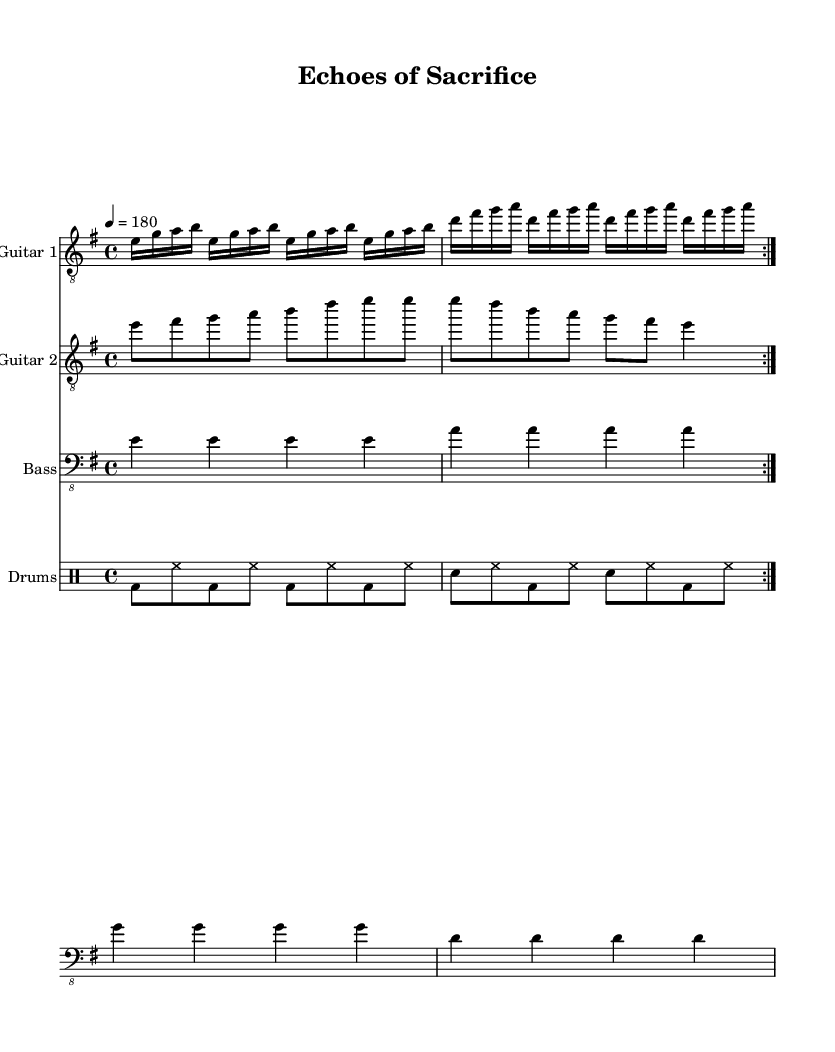What is the key signature of this music? The key signature is indicated at the beginning of the score, showing an E minor key, which contains one sharp (F#).
Answer: E minor What is the time signature of this music? The time signature appears at the start of the score, showing 4/4, which means there are four beats in a measure.
Answer: 4/4 What is the tempo marking for this piece? The tempo marking is provided in beats per minute, showing a tempo of 180, indicating the speed at which the piece should be played.
Answer: 180 How many times is the first section repeated? The first section of the guitar part shows a repeat sign, and is marked to be played twice (the volta indication).
Answer: 2 What is the rhythm pattern for the bass guitar in the first measure? The first measure of the bass guitar part consists of four quarter notes, all playing E, which establishes a steady rhythm.
Answer: Four quarter notes What genre does this piece belong to? The overall characteristics such as the aggressive guitar riffs, fast tempo, and intense drumming clearly identify it as thrash metal.
Answer: Thrash metal What instruments are included in this score? The score includes the instrumentation sections labeled for two guitars, bass, and drums, which are typical for a metal band.
Answer: Guitars, Bass, Drums 